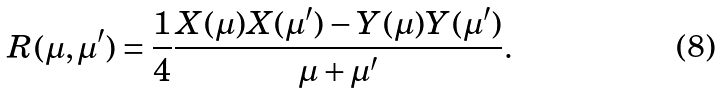<formula> <loc_0><loc_0><loc_500><loc_500>R ( \mu , \mu ^ { \prime } ) = \frac { 1 } { 4 } \frac { X ( \mu ) X ( \mu ^ { \prime } ) - Y ( \mu ) Y ( \mu ^ { \prime } ) } { \mu + \mu ^ { \prime } } .</formula> 